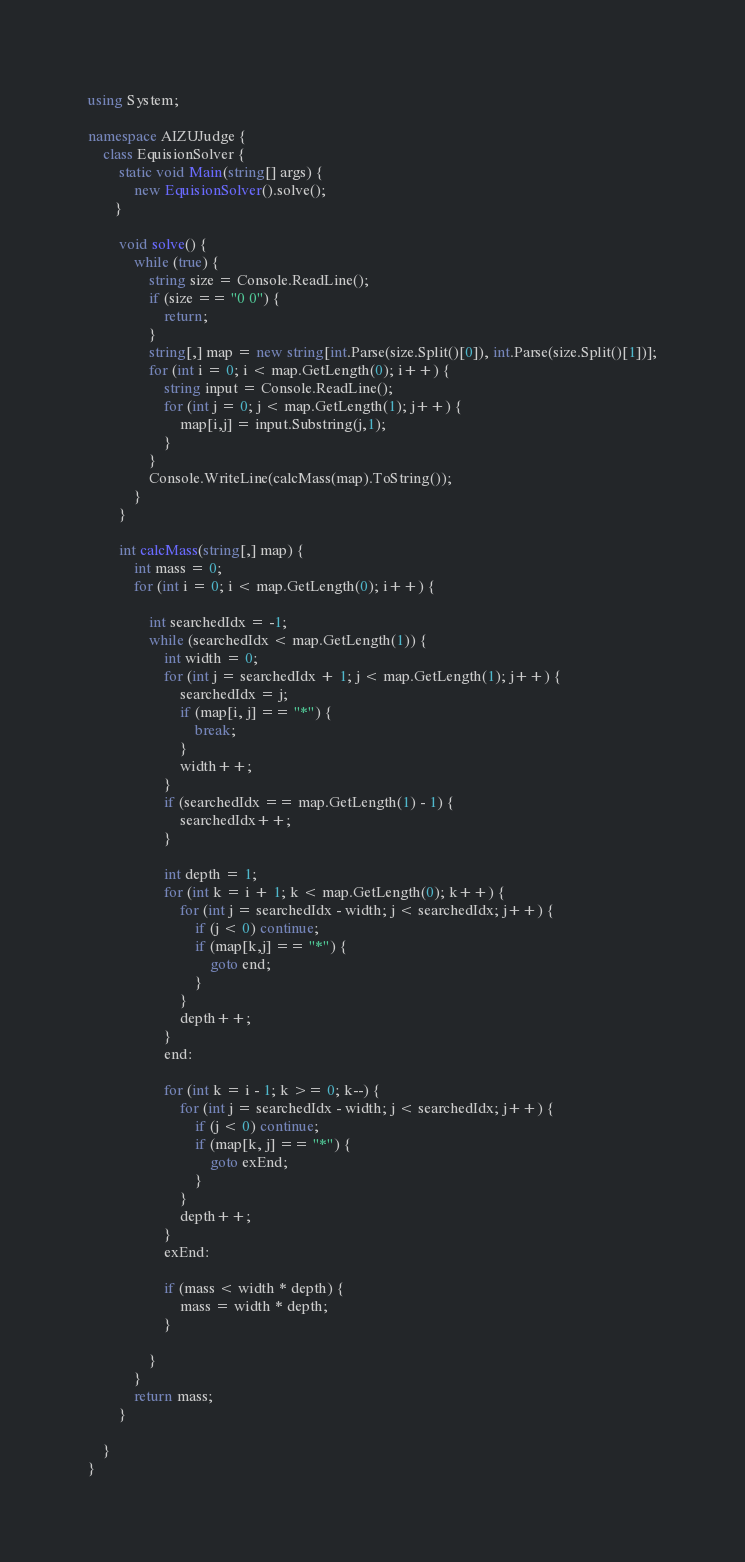Convert code to text. <code><loc_0><loc_0><loc_500><loc_500><_C#_>using System;

namespace AIZUJudge {
    class EquisionSolver {
        static void Main(string[] args) {
            new EquisionSolver().solve();
       }

        void solve() {
            while (true) {
                string size = Console.ReadLine();
                if (size == "0 0") {
                    return;
                }
                string[,] map = new string[int.Parse(size.Split()[0]), int.Parse(size.Split()[1])];
                for (int i = 0; i < map.GetLength(0); i++) {
                    string input = Console.ReadLine();
                    for (int j = 0; j < map.GetLength(1); j++) {
                        map[i,j] = input.Substring(j,1);
                    }
                }
                Console.WriteLine(calcMass(map).ToString());
            }
        }

        int calcMass(string[,] map) {
            int mass = 0;
            for (int i = 0; i < map.GetLength(0); i++) {
                
                int searchedIdx = -1;
                while (searchedIdx < map.GetLength(1)) {
                    int width = 0;
                    for (int j = searchedIdx + 1; j < map.GetLength(1); j++) {
                        searchedIdx = j;
                        if (map[i, j] == "*") {
                            break;
                        }
                        width++;
                    }
                    if (searchedIdx == map.GetLength(1) - 1) {
                        searchedIdx++;
                    }

                    int depth = 1;
                    for (int k = i + 1; k < map.GetLength(0); k++) {
                        for (int j = searchedIdx - width; j < searchedIdx; j++) {
                            if (j < 0) continue;
                            if (map[k,j] == "*") {
                                goto end;
                            }
                        }
                        depth++;
                    }
                    end:

                    for (int k = i - 1; k >= 0; k--) {
                        for (int j = searchedIdx - width; j < searchedIdx; j++) {
                            if (j < 0) continue;
                            if (map[k, j] == "*") {
                                goto exEnd;
                            }
                        }
                        depth++;
                    }
                    exEnd:

                    if (mass < width * depth) {
                        mass = width * depth;
                    }
                    
                }
            }
            return mass;
        }
        
    }
}</code> 